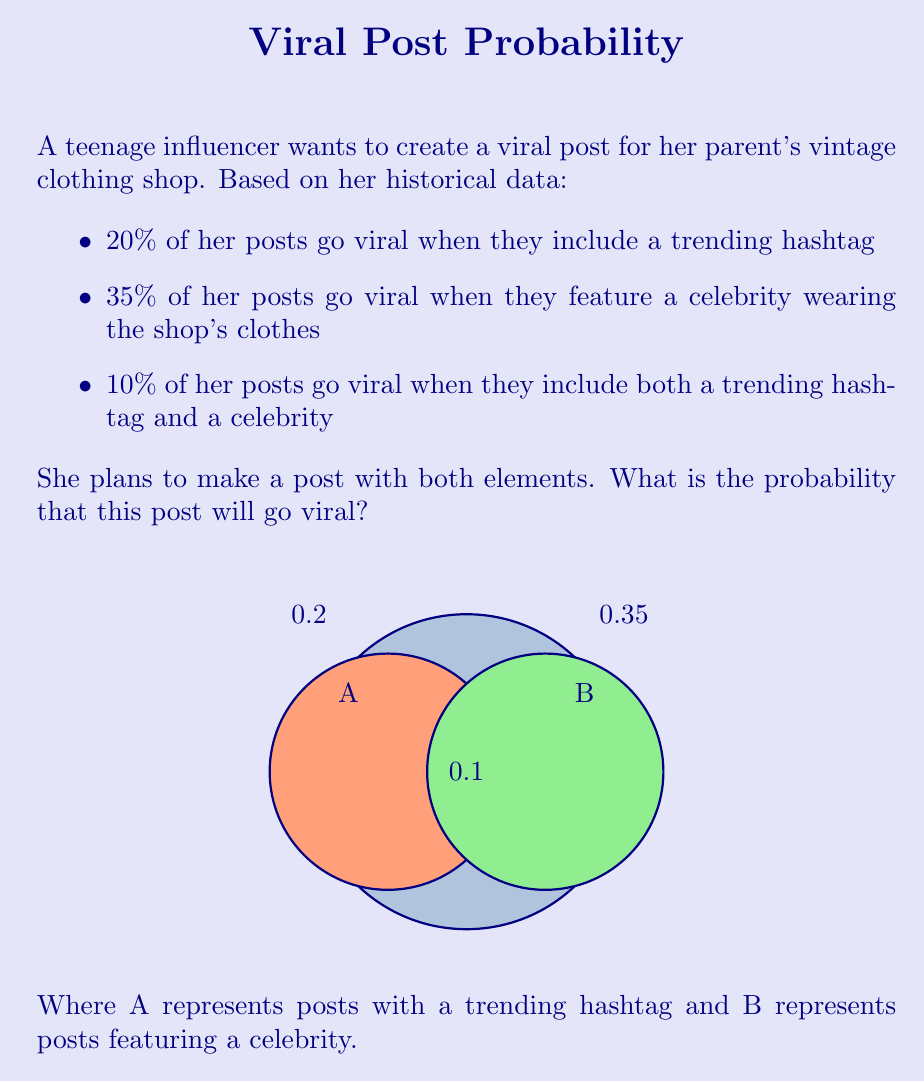Can you solve this math problem? Let's approach this step-by-step using the addition rule of probability:

1) Let A be the event of a post going viral with a trending hashtag
   P(A) = 0.20

2) Let B be the event of a post going viral featuring a celebrity
   P(B) = 0.35

3) Let P(A ∩ B) be the probability of a post going viral with both elements
   P(A ∩ B) = 0.10

4) We need to find P(A ∪ B), which is the probability of the post going viral with either or both elements

5) The addition rule of probability states:
   P(A ∪ B) = P(A) + P(B) - P(A ∩ B)

6) Substituting our values:
   P(A ∪ B) = 0.20 + 0.35 - 0.10

7) Calculating:
   P(A ∪ B) = 0.45

Therefore, the probability that the post will go viral is 0.45 or 45%.
Answer: 0.45 